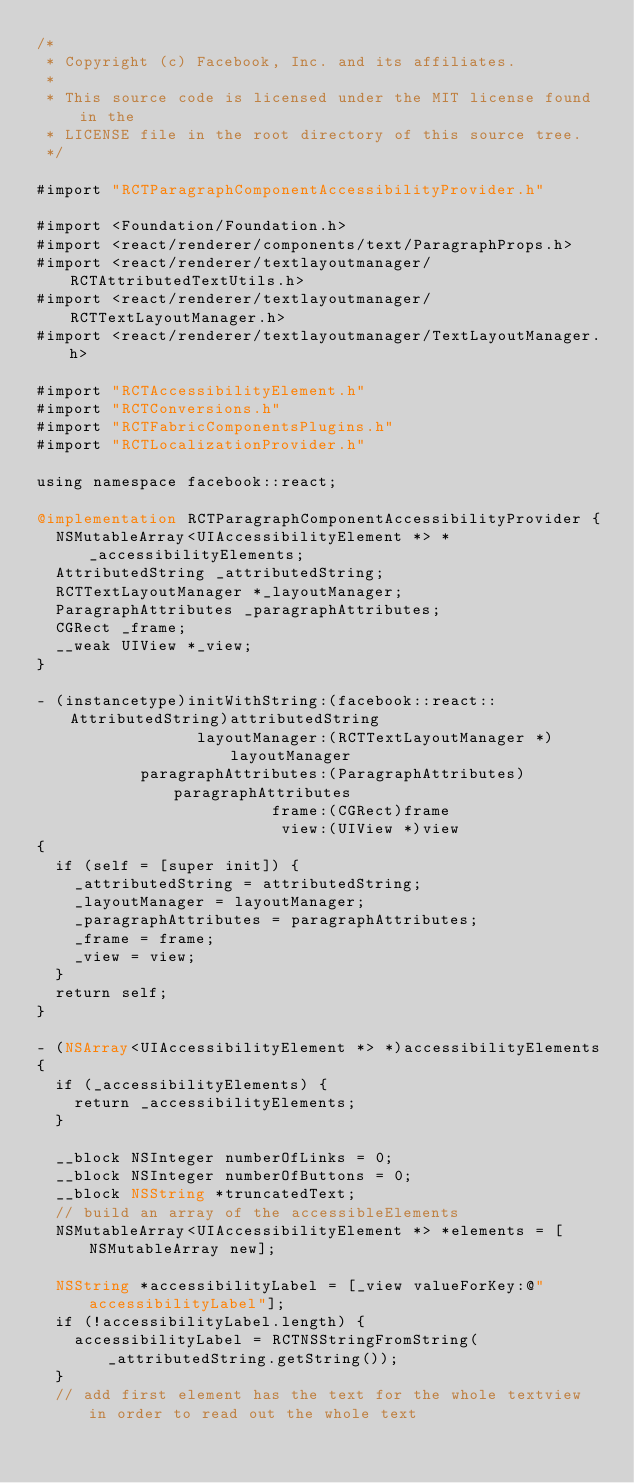Convert code to text. <code><loc_0><loc_0><loc_500><loc_500><_ObjectiveC_>/*
 * Copyright (c) Facebook, Inc. and its affiliates.
 *
 * This source code is licensed under the MIT license found in the
 * LICENSE file in the root directory of this source tree.
 */

#import "RCTParagraphComponentAccessibilityProvider.h"

#import <Foundation/Foundation.h>
#import <react/renderer/components/text/ParagraphProps.h>
#import <react/renderer/textlayoutmanager/RCTAttributedTextUtils.h>
#import <react/renderer/textlayoutmanager/RCTTextLayoutManager.h>
#import <react/renderer/textlayoutmanager/TextLayoutManager.h>

#import "RCTAccessibilityElement.h"
#import "RCTConversions.h"
#import "RCTFabricComponentsPlugins.h"
#import "RCTLocalizationProvider.h"

using namespace facebook::react;

@implementation RCTParagraphComponentAccessibilityProvider {
  NSMutableArray<UIAccessibilityElement *> *_accessibilityElements;
  AttributedString _attributedString;
  RCTTextLayoutManager *_layoutManager;
  ParagraphAttributes _paragraphAttributes;
  CGRect _frame;
  __weak UIView *_view;
}

- (instancetype)initWithString:(facebook::react::AttributedString)attributedString
                 layoutManager:(RCTTextLayoutManager *)layoutManager
           paragraphAttributes:(ParagraphAttributes)paragraphAttributes
                         frame:(CGRect)frame
                          view:(UIView *)view
{
  if (self = [super init]) {
    _attributedString = attributedString;
    _layoutManager = layoutManager;
    _paragraphAttributes = paragraphAttributes;
    _frame = frame;
    _view = view;
  }
  return self;
}

- (NSArray<UIAccessibilityElement *> *)accessibilityElements
{
  if (_accessibilityElements) {
    return _accessibilityElements;
  }

  __block NSInteger numberOfLinks = 0;
  __block NSInteger numberOfButtons = 0;
  __block NSString *truncatedText;
  // build an array of the accessibleElements
  NSMutableArray<UIAccessibilityElement *> *elements = [NSMutableArray new];

  NSString *accessibilityLabel = [_view valueForKey:@"accessibilityLabel"];
  if (!accessibilityLabel.length) {
    accessibilityLabel = RCTNSStringFromString(_attributedString.getString());
  }
  // add first element has the text for the whole textview in order to read out the whole text</code> 